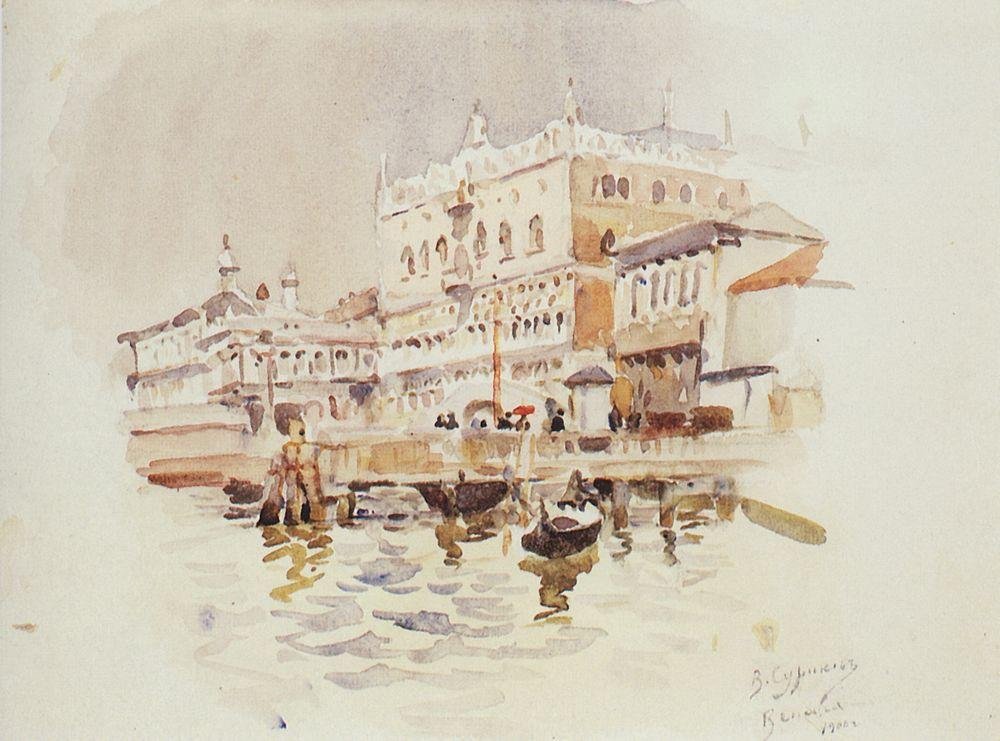What do you think is going on in this snapshot? This painting captures a serene yet lively scene of a grand palace along the Grand Canal in Venice. The soft, muted colors and blurred lines suggest it’s painted in an impressionistic style, focusing on the play of light and reflections over strict realism. The palace is richly detailed, hinting at the architectural splendor Venice is celebrated for, while the presence of boats indicates the daily bustle and importance of waterways in Venetian life. The artwork invites the viewer to appreciate both the historical architecture and the dynamic everyday life of Venice. 